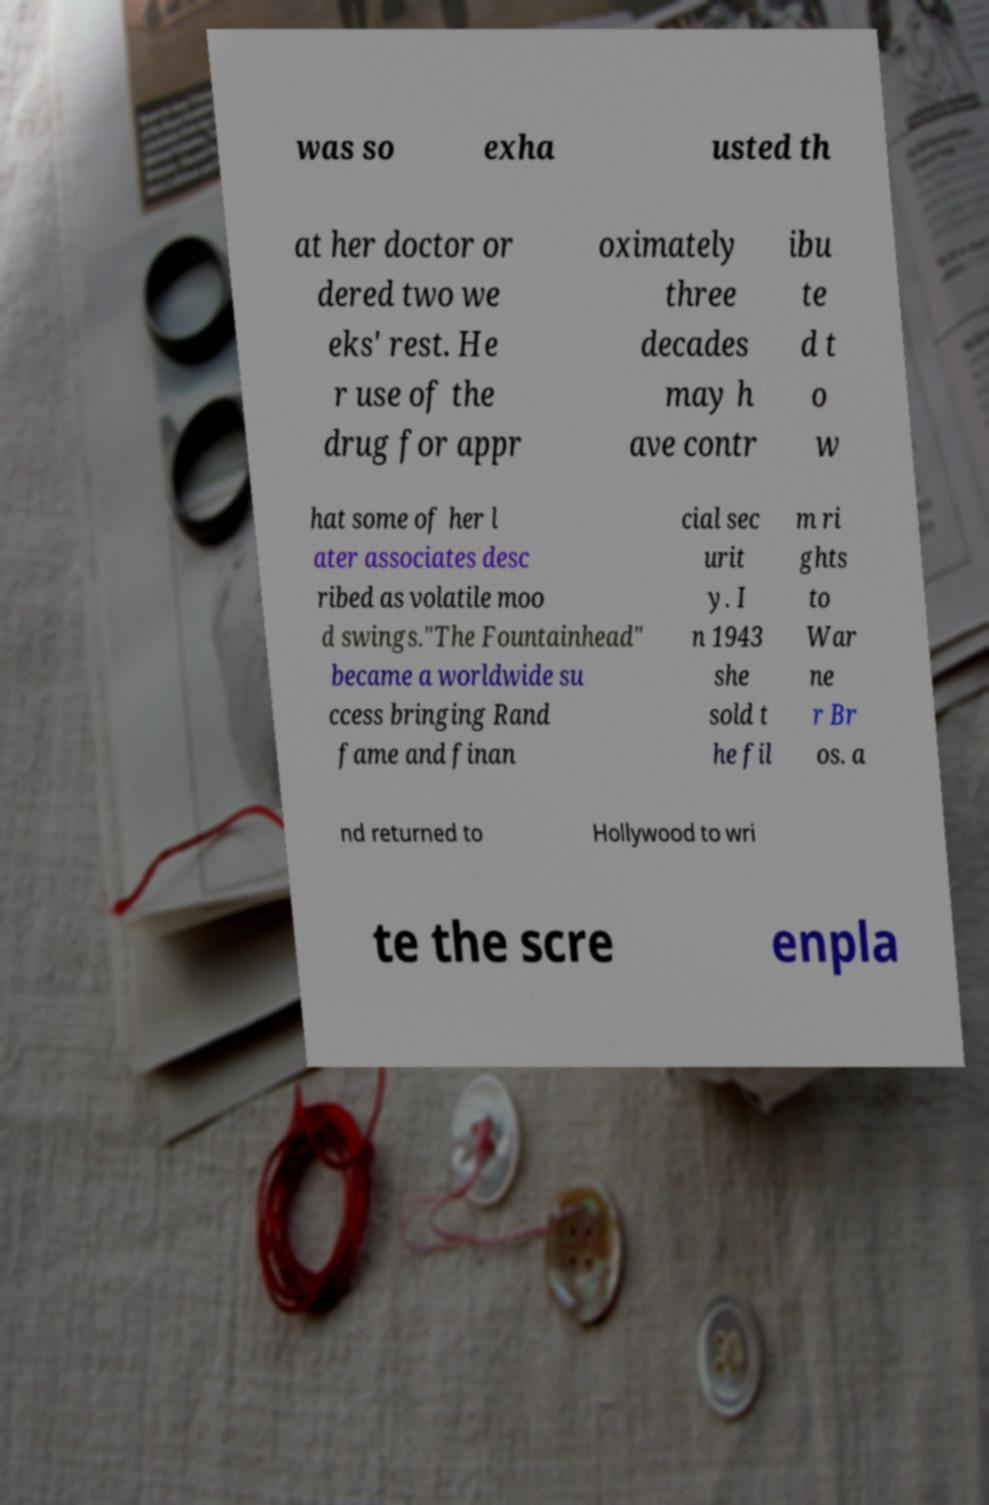I need the written content from this picture converted into text. Can you do that? was so exha usted th at her doctor or dered two we eks' rest. He r use of the drug for appr oximately three decades may h ave contr ibu te d t o w hat some of her l ater associates desc ribed as volatile moo d swings."The Fountainhead" became a worldwide su ccess bringing Rand fame and finan cial sec urit y. I n 1943 she sold t he fil m ri ghts to War ne r Br os. a nd returned to Hollywood to wri te the scre enpla 